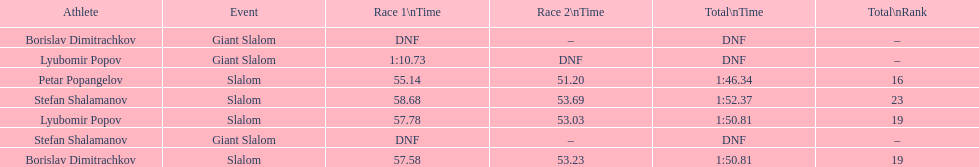Who came after borislav dimitrachkov and it's time for slalom Petar Popangelov. 